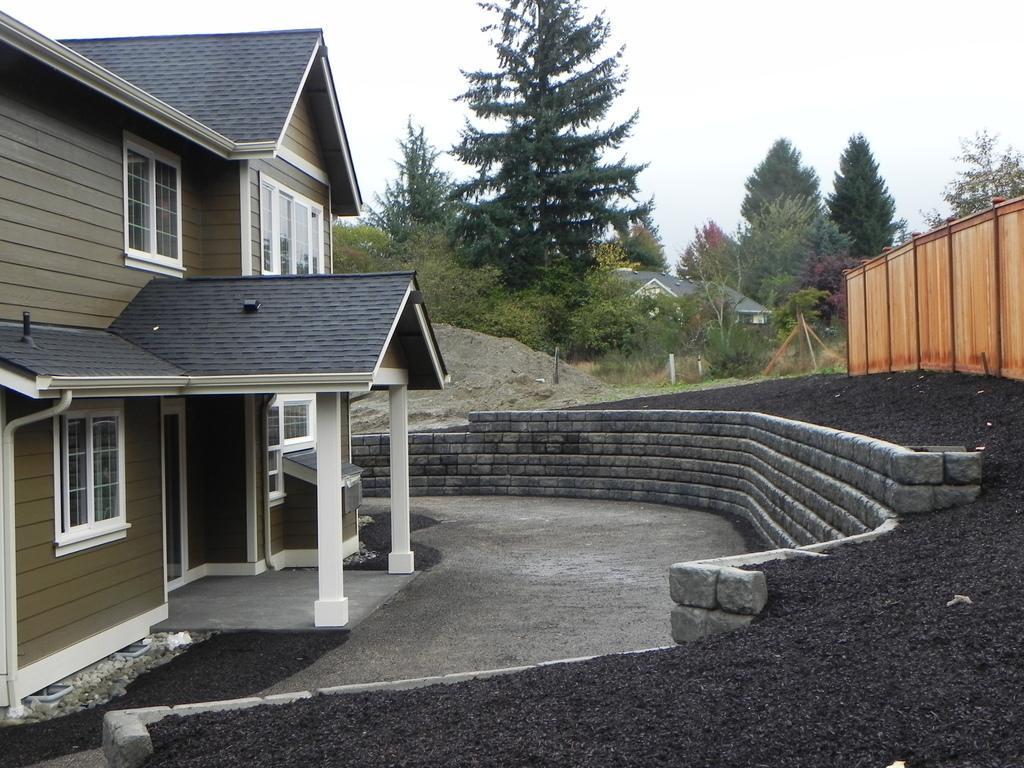In one or two sentences, can you explain what this image depicts? In this image we can see the houses with roof and windows. We can also see a wooden fence, a wall built with stones, a heap of sand, a group of trees and the sky which looks cloudy. 